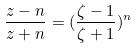Convert formula to latex. <formula><loc_0><loc_0><loc_500><loc_500>\frac { z - n } { z + n } = ( \frac { \zeta - 1 } { \zeta + 1 } ) ^ { n }</formula> 